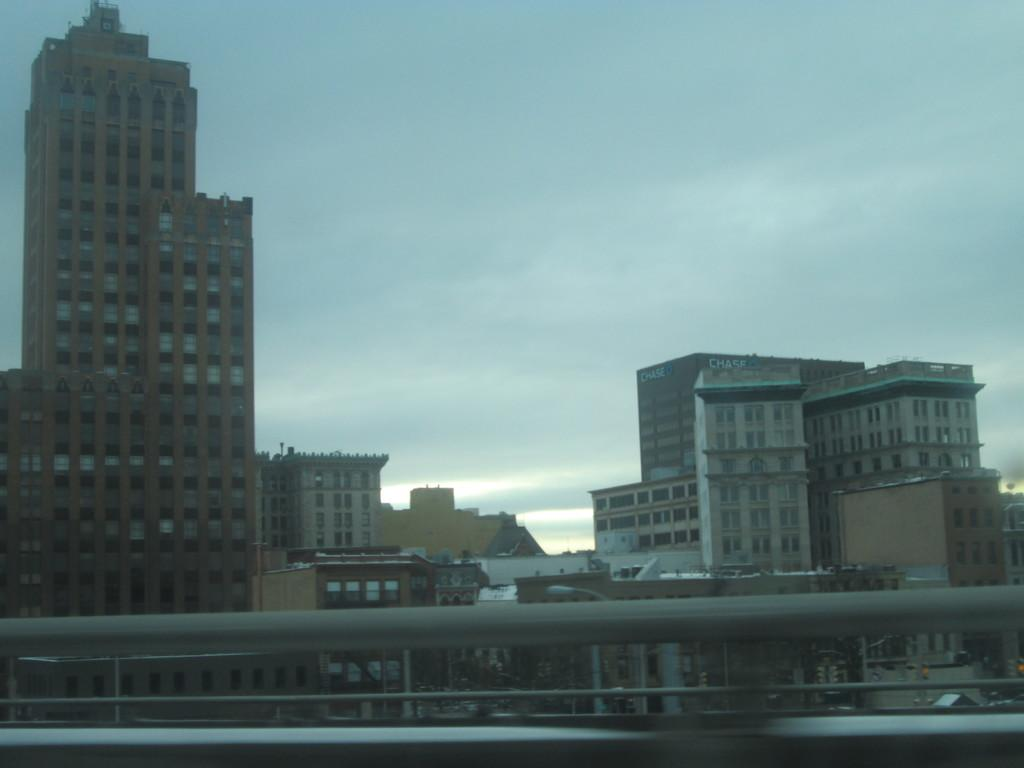What object is present in the foreground of the image? There is a rod in the image. What can be seen in the background of the image? There are buildings in the background of the image. What colors are the buildings in the image? The buildings are in brown, cream, and white colors. What is visible above the buildings in the image? The sky is visible in the image. What colors are present in the sky in the image? The sky is a combination of white and blue colors. Where is the seat located in the image? There is no seat present in the image. What type of basket can be seen in the image? There is no basket present in the image. 